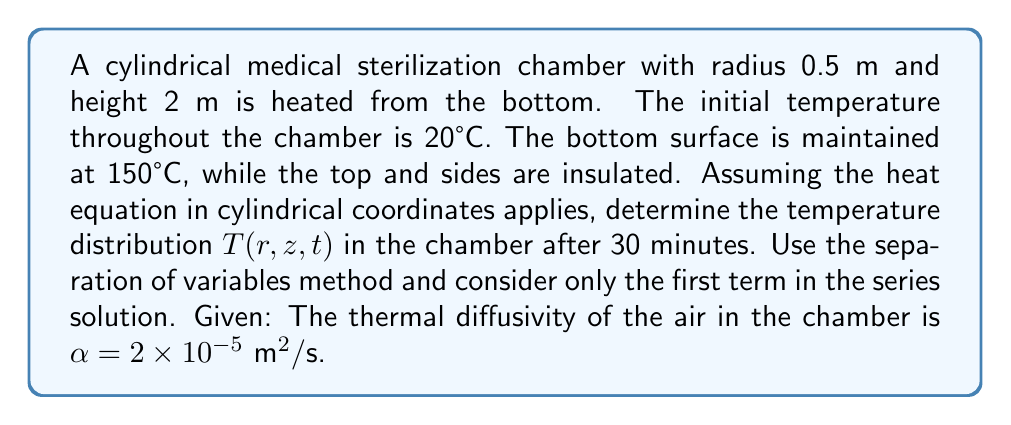Solve this math problem. 1) The heat equation in cylindrical coordinates is:

   $$\frac{\partial T}{\partial t} = \alpha \left(\frac{\partial^2 T}{\partial r^2} + \frac{1}{r}\frac{\partial T}{\partial r} + \frac{\partial^2 T}{\partial z^2}\right)$$

2) Boundary conditions:
   $T(r,0,t) = 150°C$
   $\frac{\partial T}{\partial r}(R,z,t) = 0$
   $\frac{\partial T}{\partial z}(r,L,t) = 0$
   where $R = 0.5$ m and $L = 2$ m

3) Initial condition:
   $T(r,z,0) = 20°C$

4) Using separation of variables, we assume $T(r,z,t) = R(r)Z(z)G(t)$

5) Solving the resulting ODEs and applying boundary conditions:

   $R(r) = J_0(\lambda_n r)$
   $Z(z) = \cos(\mu_m z)$
   $G(t) = e^{-\alpha(\lambda_n^2 + \mu_m^2)t}$

   where $J_0$ is the Bessel function of the first kind of order zero,
   $\lambda_n$ are roots of $J_1(\lambda_n R) = 0$, and $\mu_m = \frac{(2m-1)\pi}{2L}$

6) The general solution is:

   $$T(r,z,t) = 150 + \sum_{n=1}^{\infty}\sum_{m=1}^{\infty} A_{nm}J_0(\lambda_n r)\cos(\mu_m z)e^{-\alpha(\lambda_n^2 + \mu_m^2)t}$$

7) For the first term (n=1, m=1):
   $\lambda_1 \approx 3.8317/R = 7.6634$ m^(-1)
   $\mu_1 = \pi/(2L) = 0.7854$ m^(-1)

8) Coefficient $A_{11}$ is found using the initial condition:

   $$A_{11} = \frac{4(20-150)}{J_0(\lambda_1 R)RL} \int_0^R rJ_0(\lambda_1 r)dr \int_0^L \cos(\mu_1 z)dz \approx -207.3$$

9) After 30 minutes (1800 seconds), the temperature distribution is:

   $$T(r,z,1800) \approx 150 - 207.3J_0(7.6634r)\cos(0.7854z)e^{-2\times10^{-5}(7.6634^2 + 0.7854^2)1800}$$
Answer: $T(r,z,1800) \approx 150 - 207.3J_0(7.6634r)\cos(0.7854z)e^{-21.3}$ 